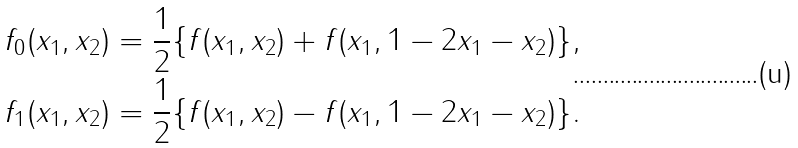<formula> <loc_0><loc_0><loc_500><loc_500>f _ { 0 } ( x _ { 1 } , x _ { 2 } ) = \frac { 1 } { 2 } \{ f ( x _ { 1 } , x _ { 2 } ) + f ( x _ { 1 } , 1 - 2 x _ { 1 } - x _ { 2 } ) \} , \\ f _ { 1 } ( x _ { 1 } , x _ { 2 } ) = \frac { 1 } { 2 } \{ f ( x _ { 1 } , x _ { 2 } ) - f ( x _ { 1 } , 1 - 2 x _ { 1 } - x _ { 2 } ) \} .</formula> 